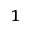Convert formula to latex. <formula><loc_0><loc_0><loc_500><loc_500>^ { 1 }</formula> 